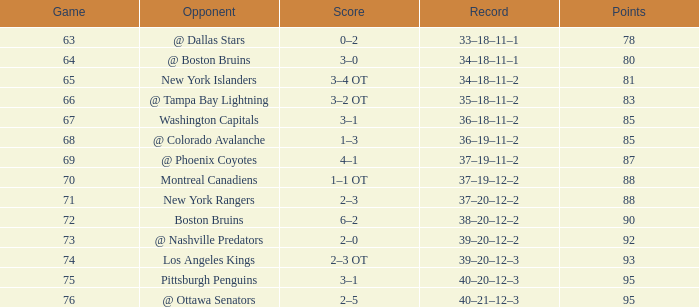How many Points have a Record of 40–21–12–3, and a March larger than 28? 0.0. 